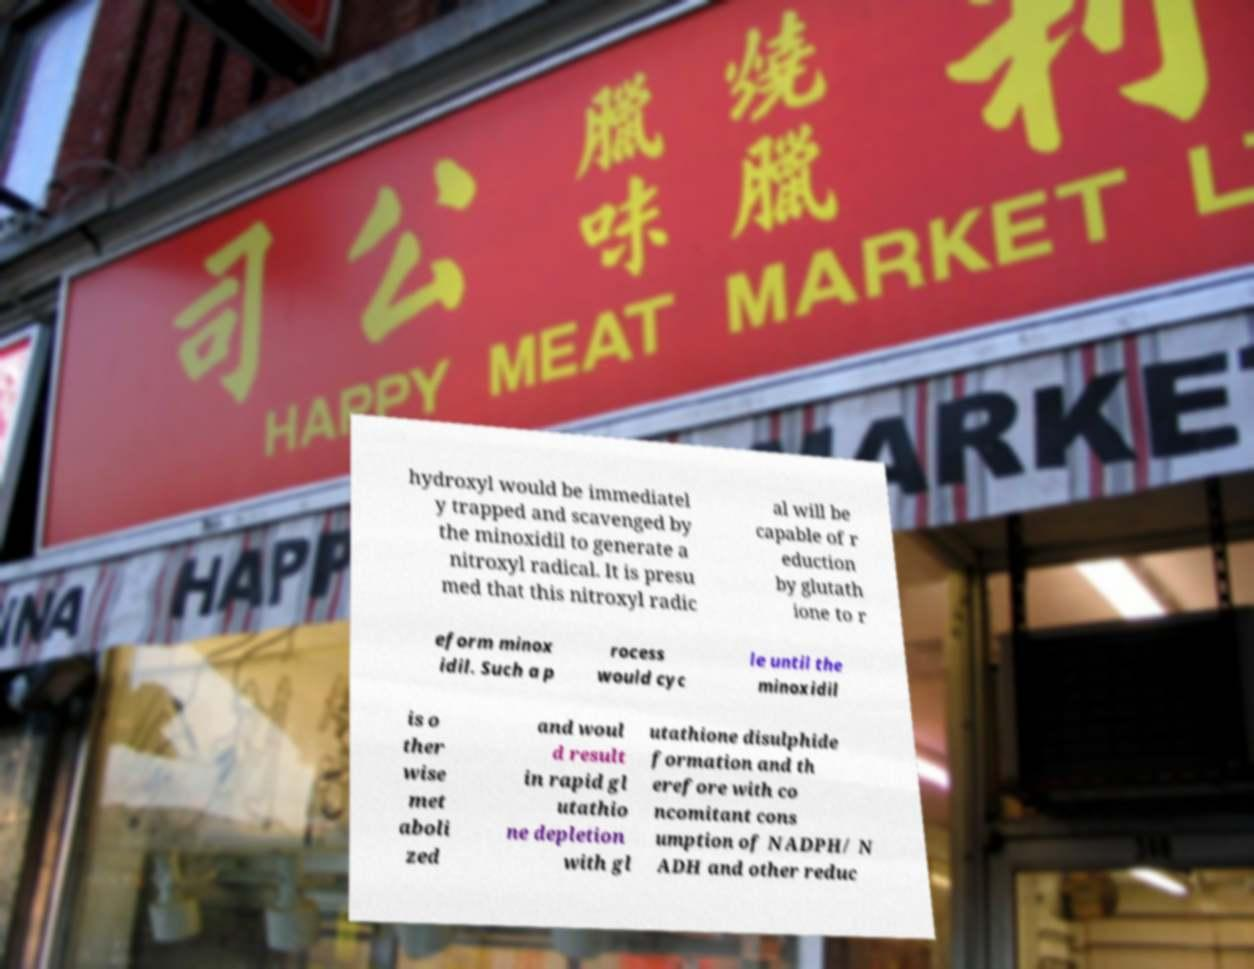For documentation purposes, I need the text within this image transcribed. Could you provide that? hydroxyl would be immediatel y trapped and scavenged by the minoxidil to generate a nitroxyl radical. It is presu med that this nitroxyl radic al will be capable of r eduction by glutath ione to r eform minox idil. Such a p rocess would cyc le until the minoxidil is o ther wise met aboli zed and woul d result in rapid gl utathio ne depletion with gl utathione disulphide formation and th erefore with co ncomitant cons umption of NADPH/ N ADH and other reduc 